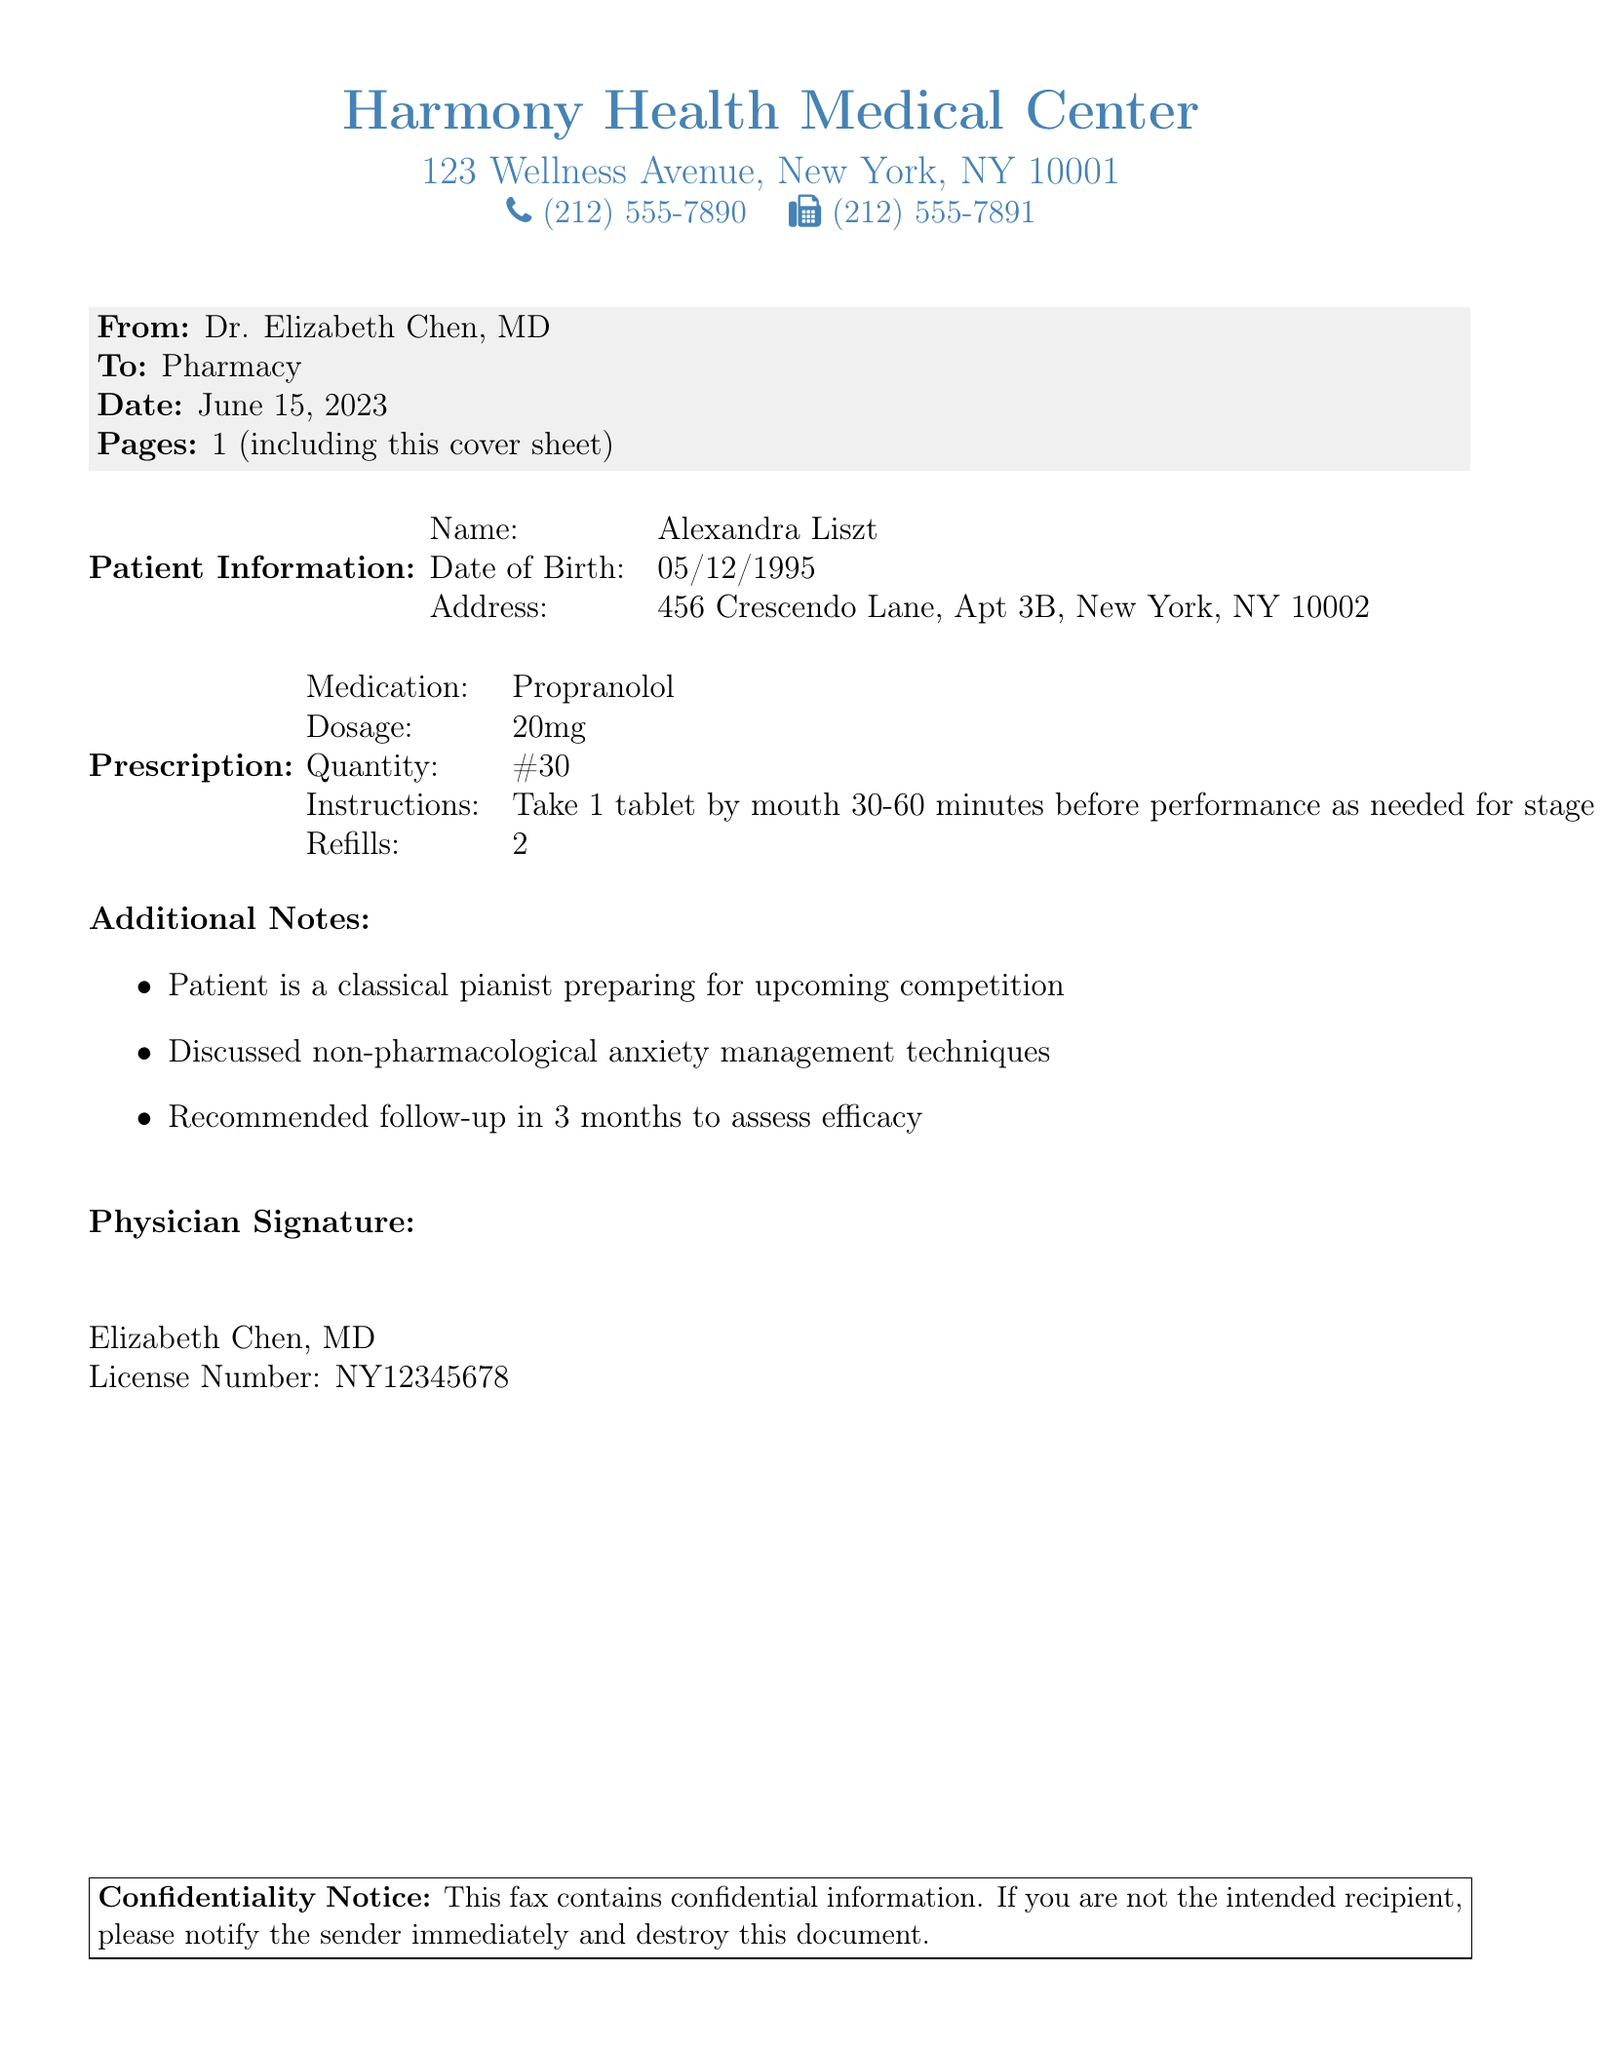what is the name of the physician? The physician's name is listed at the end of the document.
Answer: Dr. Elizabeth Chen, MD what is the date of the prescription? The date is specified in the header section of the fax.
Answer: June 15, 2023 how many tablets are prescribed? The quantity of the prescribed medication is mentioned in the prescription section.
Answer: #30 what medication is prescribed for performance anxiety? The prescribed medication is clearly stated in the document's prescription section.
Answer: Propranolol what are the refills allowed for the prescription? The number of refills is stated in the prescription details.
Answer: 2 what instructions are given for taking the medication? The instructions for the medication are included in the prescription section.
Answer: Take 1 tablet by mouth 30-60 minutes before performance as needed for stage fright what is the patient's name? The patient's name is indicated in the patient information section of the document.
Answer: Alexandra Liszt what type of management techniques were discussed besides medication? The additional notes mention other techniques discussed.
Answer: Non-pharmacological anxiety management techniques how long should the patient wait for a follow-up appointment? The follow-up time frame is noted in the additional notes section.
Answer: 3 months 